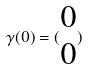<formula> <loc_0><loc_0><loc_500><loc_500>\gamma ( 0 ) = ( \begin{matrix} 0 \\ 0 \end{matrix} )</formula> 